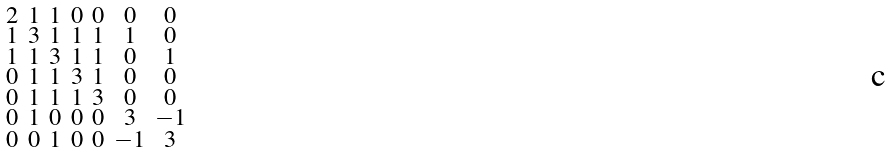Convert formula to latex. <formula><loc_0><loc_0><loc_500><loc_500>\begin{smallmatrix} 2 & 1 & 1 & 0 & 0 & 0 & 0 \\ 1 & 3 & 1 & 1 & 1 & 1 & 0 \\ 1 & 1 & 3 & 1 & 1 & 0 & 1 \\ 0 & 1 & 1 & 3 & 1 & 0 & 0 \\ 0 & 1 & 1 & 1 & 3 & 0 & 0 \\ 0 & 1 & 0 & 0 & 0 & 3 & - 1 \\ 0 & 0 & 1 & 0 & 0 & - 1 & 3 \end{smallmatrix}</formula> 